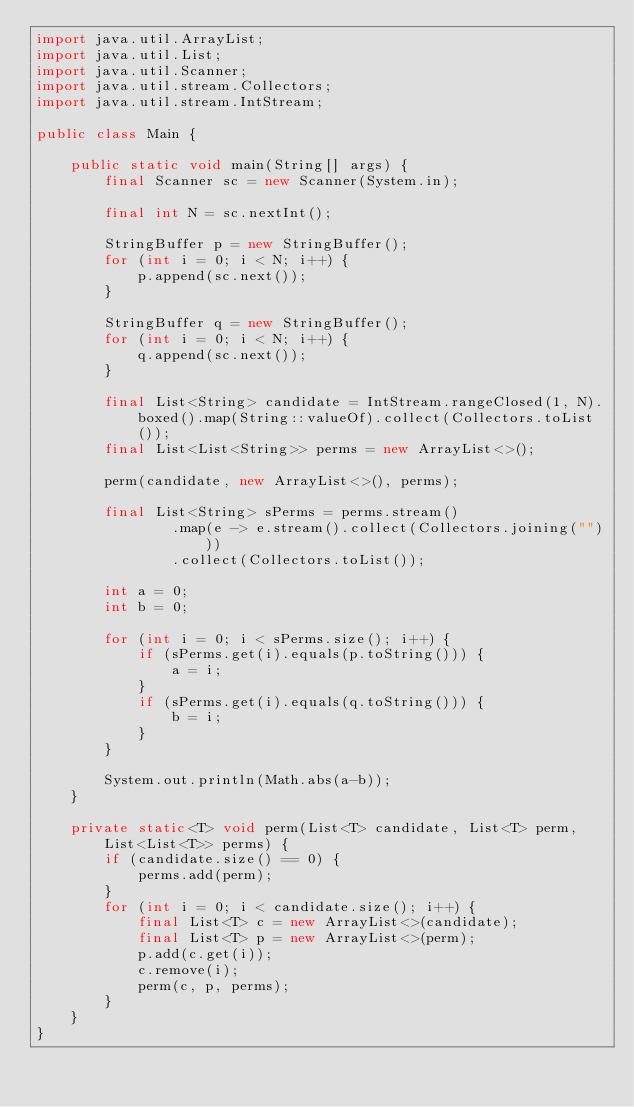Convert code to text. <code><loc_0><loc_0><loc_500><loc_500><_Java_>import java.util.ArrayList;
import java.util.List;
import java.util.Scanner;
import java.util.stream.Collectors;
import java.util.stream.IntStream;

public class Main {

    public static void main(String[] args) {
        final Scanner sc = new Scanner(System.in);

        final int N = sc.nextInt();

        StringBuffer p = new StringBuffer();
        for (int i = 0; i < N; i++) {
            p.append(sc.next());
        }

        StringBuffer q = new StringBuffer();
        for (int i = 0; i < N; i++) {
            q.append(sc.next());
        }

        final List<String> candidate = IntStream.rangeClosed(1, N).boxed().map(String::valueOf).collect(Collectors.toList());
        final List<List<String>> perms = new ArrayList<>();

        perm(candidate, new ArrayList<>(), perms);

        final List<String> sPerms = perms.stream()
                .map(e -> e.stream().collect(Collectors.joining("")))
                .collect(Collectors.toList());

        int a = 0;
        int b = 0;

        for (int i = 0; i < sPerms.size(); i++) {
            if (sPerms.get(i).equals(p.toString())) {
                a = i;
            }
            if (sPerms.get(i).equals(q.toString())) {
                b = i;
            }
        }

        System.out.println(Math.abs(a-b));
    }

    private static<T> void perm(List<T> candidate, List<T> perm, List<List<T>> perms) {
        if (candidate.size() == 0) {
            perms.add(perm);
        }
        for (int i = 0; i < candidate.size(); i++) {
            final List<T> c = new ArrayList<>(candidate);
            final List<T> p = new ArrayList<>(perm);
            p.add(c.get(i));
            c.remove(i);
            perm(c, p, perms);
        }
    }
}
</code> 